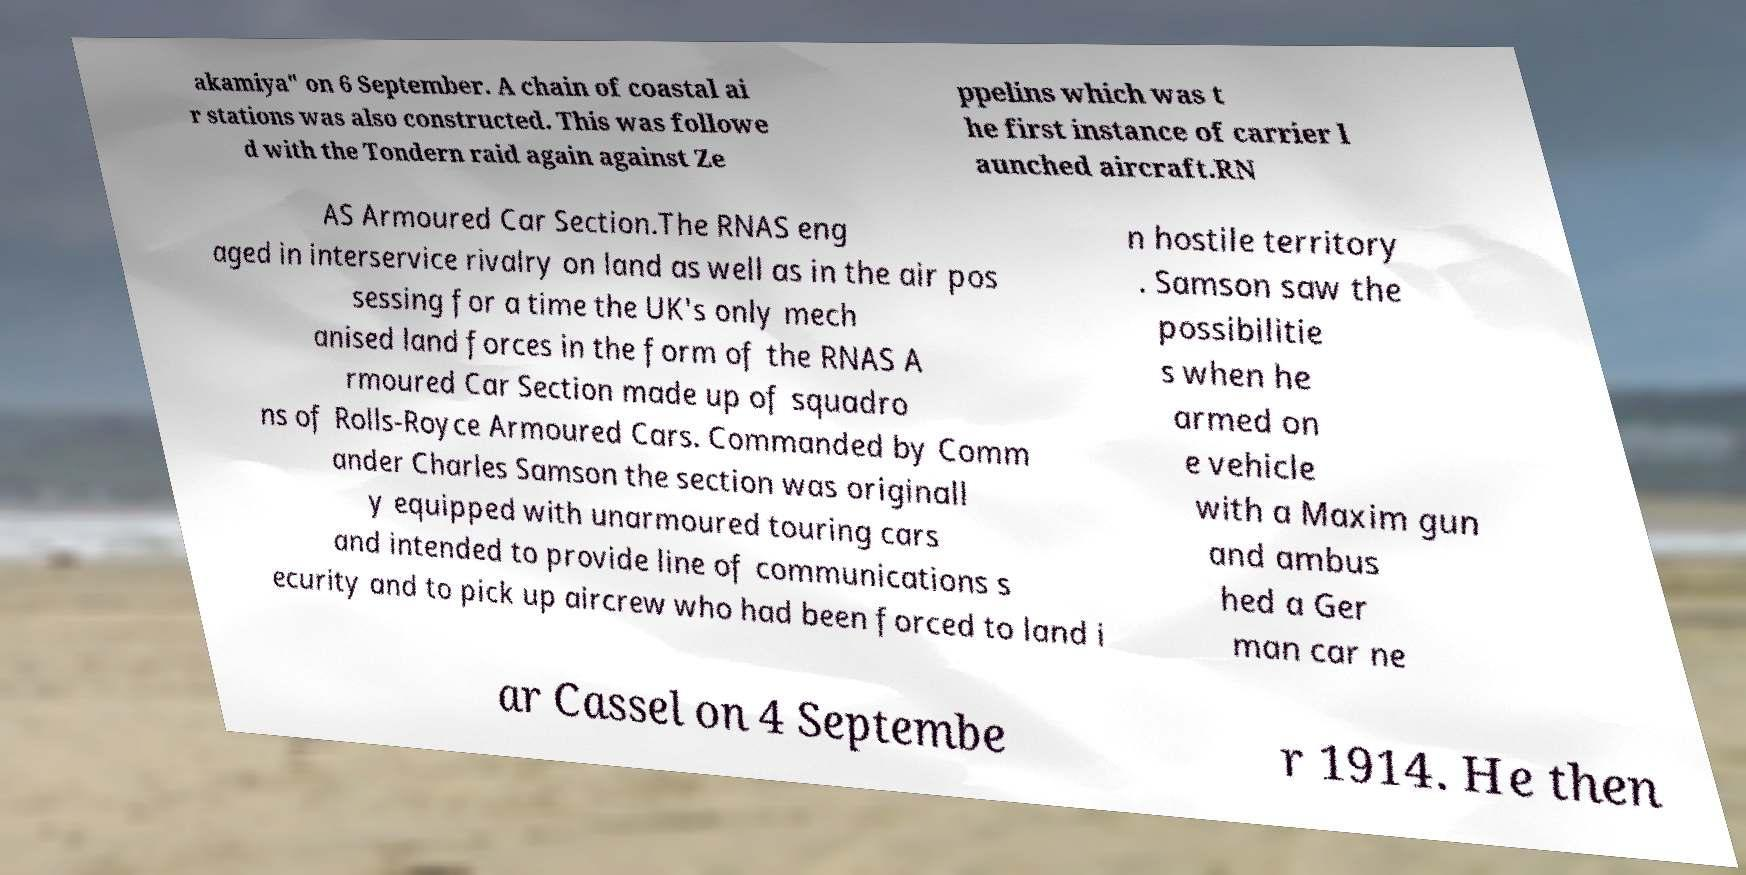Could you assist in decoding the text presented in this image and type it out clearly? akamiya" on 6 September. A chain of coastal ai r stations was also constructed. This was followe d with the Tondern raid again against Ze ppelins which was t he first instance of carrier l aunched aircraft.RN AS Armoured Car Section.The RNAS eng aged in interservice rivalry on land as well as in the air pos sessing for a time the UK's only mech anised land forces in the form of the RNAS A rmoured Car Section made up of squadro ns of Rolls-Royce Armoured Cars. Commanded by Comm ander Charles Samson the section was originall y equipped with unarmoured touring cars and intended to provide line of communications s ecurity and to pick up aircrew who had been forced to land i n hostile territory . Samson saw the possibilitie s when he armed on e vehicle with a Maxim gun and ambus hed a Ger man car ne ar Cassel on 4 Septembe r 1914. He then 